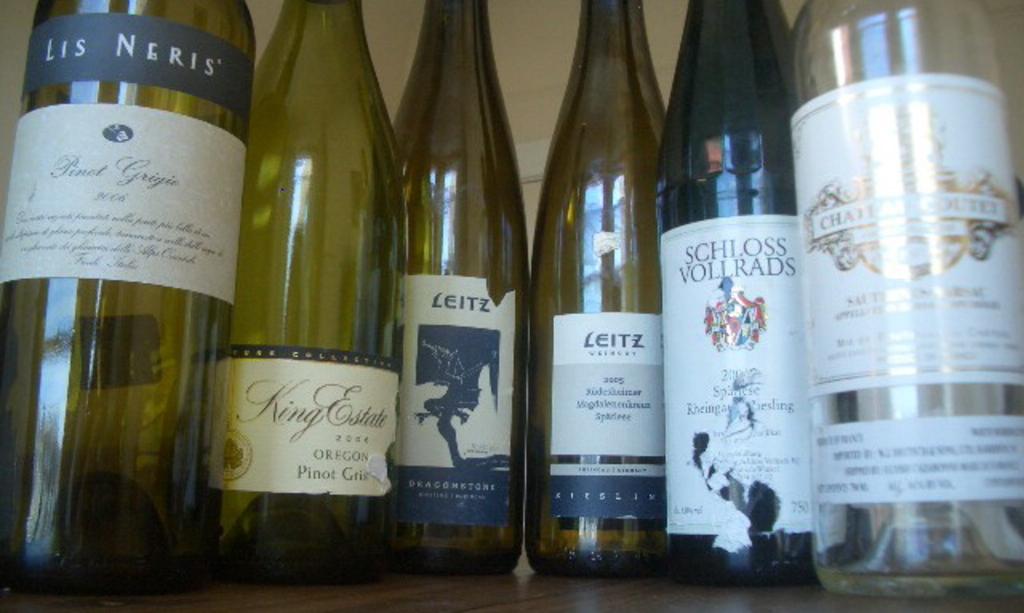What is printed on the slim black label at the top of the wine bottle on the left?
Ensure brevity in your answer.  Lis neris. What´s the brand of the second bottle on the left?
Offer a very short reply. King estate. 